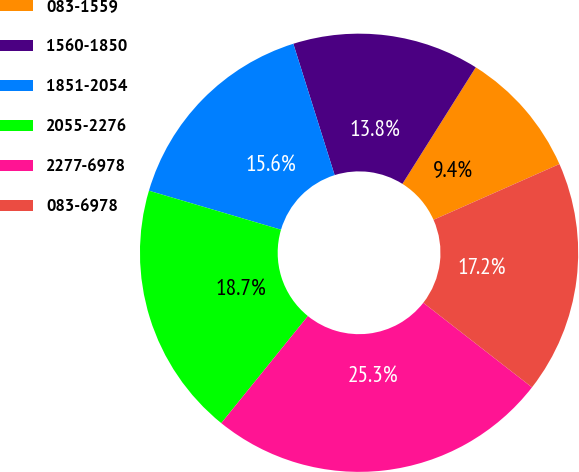<chart> <loc_0><loc_0><loc_500><loc_500><pie_chart><fcel>083-1559<fcel>1560-1850<fcel>1851-2054<fcel>2055-2276<fcel>2277-6978<fcel>083-6978<nl><fcel>9.43%<fcel>13.79%<fcel>15.58%<fcel>18.75%<fcel>25.3%<fcel>17.16%<nl></chart> 